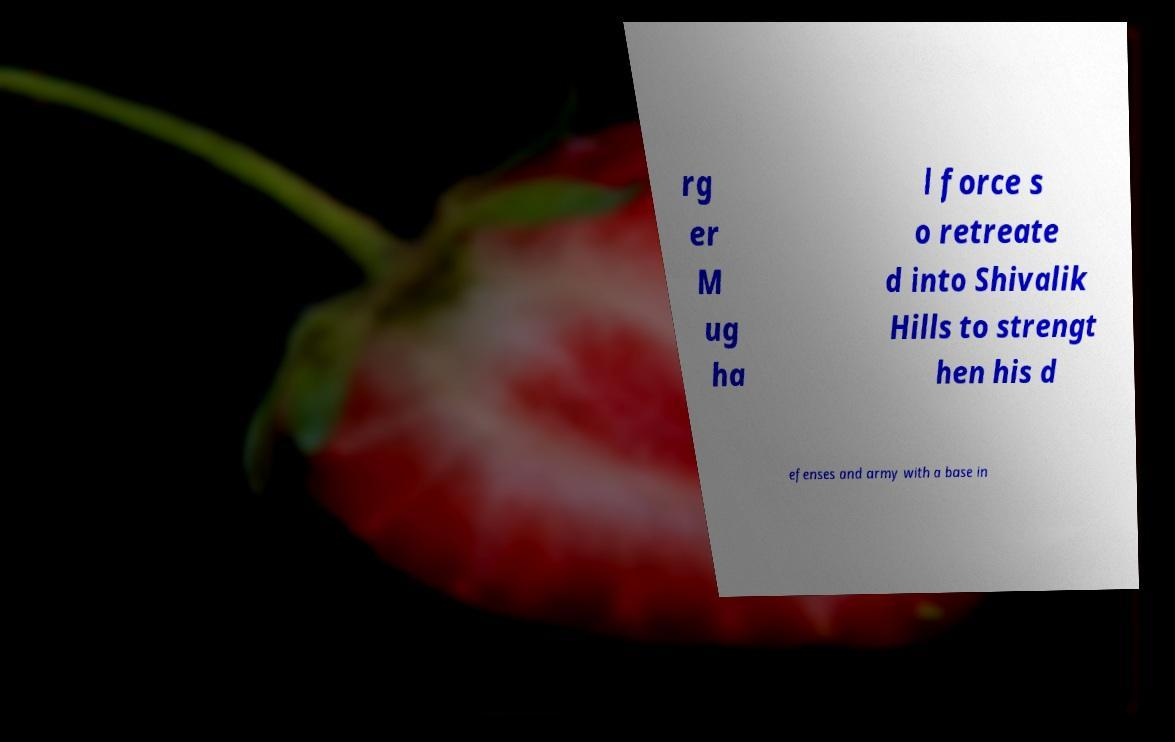Can you read and provide the text displayed in the image?This photo seems to have some interesting text. Can you extract and type it out for me? rg er M ug ha l force s o retreate d into Shivalik Hills to strengt hen his d efenses and army with a base in 